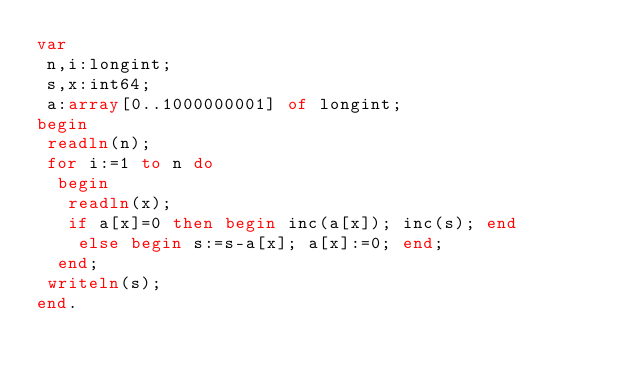<code> <loc_0><loc_0><loc_500><loc_500><_Pascal_>var
 n,i:longint;
 s,x:int64;
 a:array[0..1000000001] of longint;
begin
 readln(n);
 for i:=1 to n do 
  begin
   readln(x);
   if a[x]=0 then begin inc(a[x]); inc(s); end
    else begin s:=s-a[x]; a[x]:=0; end;
  end;
 writeln(s);
end.</code> 